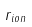Convert formula to latex. <formula><loc_0><loc_0><loc_500><loc_500>r _ { i o n }</formula> 